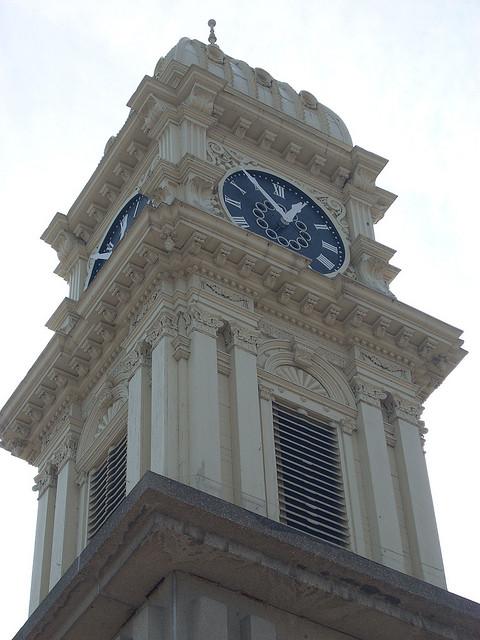Is the building made of brick?
Give a very brief answer. No. How many pillars are at the top of the building?
Be succinct. 4. How many clocks are not visible?
Answer briefly. 2. What time is it?
Write a very short answer. 12:55. What time does the clock say?
Concise answer only. 12:55. 